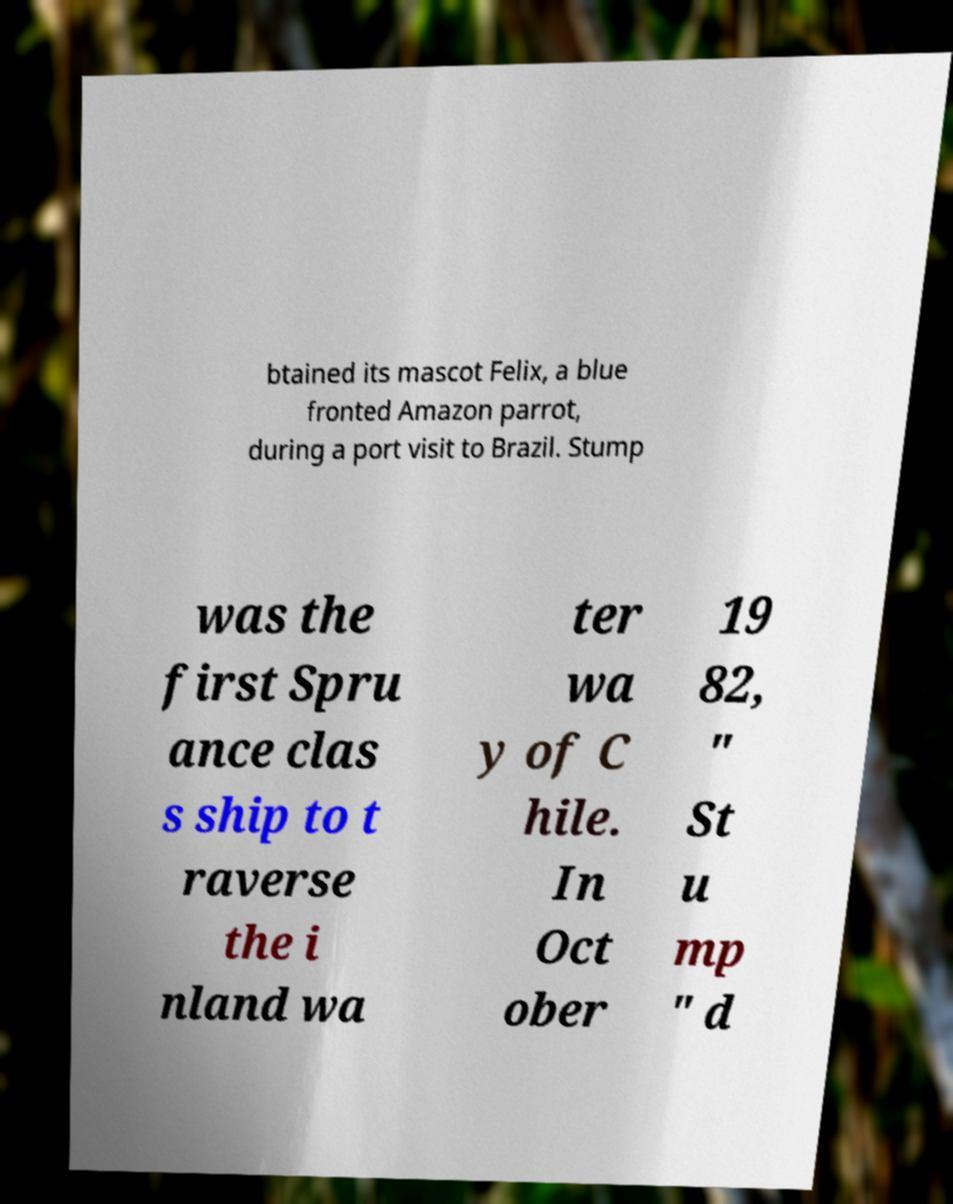What messages or text are displayed in this image? I need them in a readable, typed format. btained its mascot Felix, a blue fronted Amazon parrot, during a port visit to Brazil. Stump was the first Spru ance clas s ship to t raverse the i nland wa ter wa y of C hile. In Oct ober 19 82, " St u mp " d 